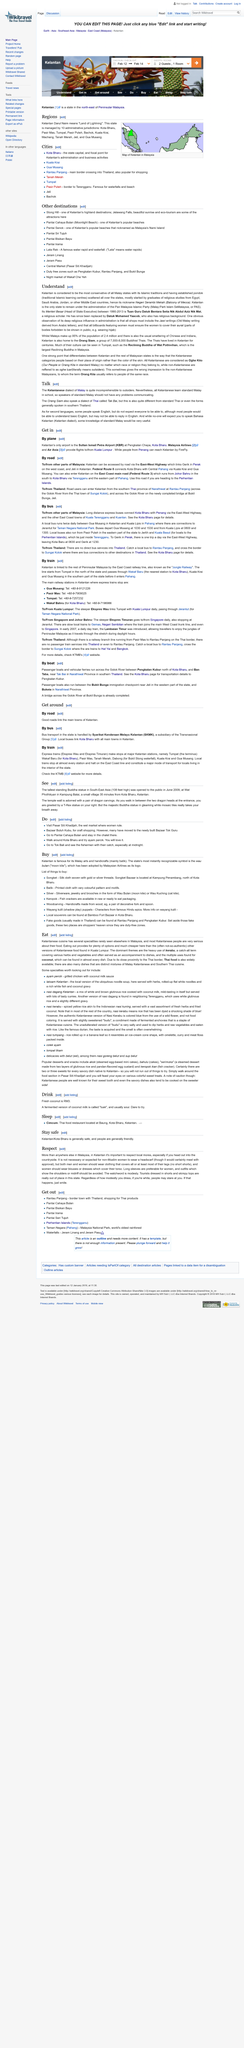Indicate a few pertinent items in this graphic. Kelantan is considered the most conservative of all Malay states due to its strong Islamic traditions and the establishment of pondoks, or Islamic religious schools. Kelantan is considered the most conservative of all Malay states, as understood by many. Datuk Mohamed Yaacob took over the position of Tuan Guru Datuk Bentara Setia Nik Abdul Aziz Nik Mat. 